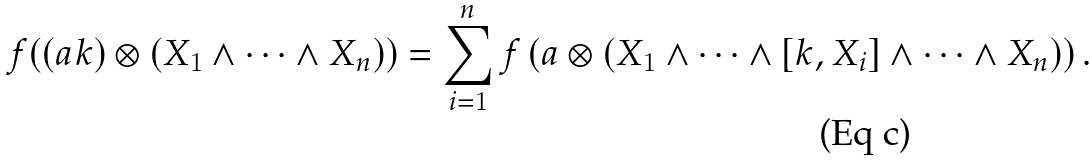Convert formula to latex. <formula><loc_0><loc_0><loc_500><loc_500>f ( ( a k ) \otimes ( X _ { 1 } \wedge \cdots \wedge X _ { n } ) ) = \sum _ { i = 1 } ^ { n } f \left ( a \otimes \left ( X _ { 1 } \wedge \cdots \wedge [ k , X _ { i } ] \wedge \cdots \wedge X _ { n } \right ) \right ) .</formula> 